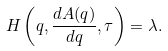<formula> <loc_0><loc_0><loc_500><loc_500>H \left ( q , \frac { d A ( q ) } { d q } , \tau \right ) = \lambda .</formula> 